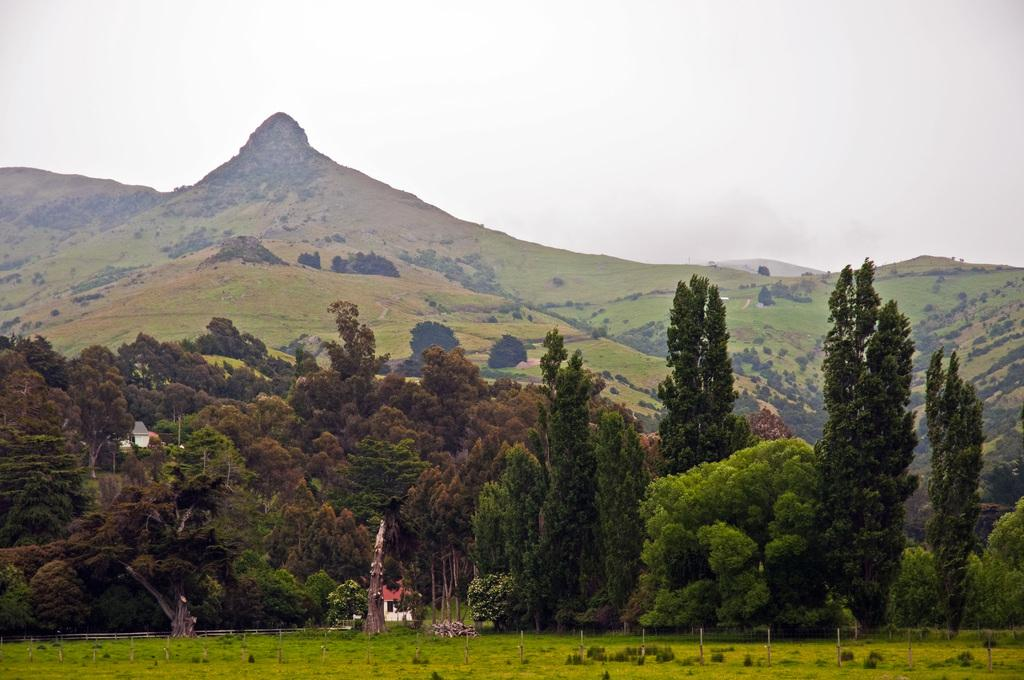What type of vegetation is present on the ground in the image? There is grass on the ground in the image. What other natural elements can be seen in the image? There are trees visible in the image. What can be seen in the distance in the image? Hills are visible in the background of the image. What is visible above the hills in the image? The sky is visible in the background of the image. What type of jewel is being played on the instrument in the image? There is no jewel or instrument present in the image; it features grass, trees, hills, and the sky. 